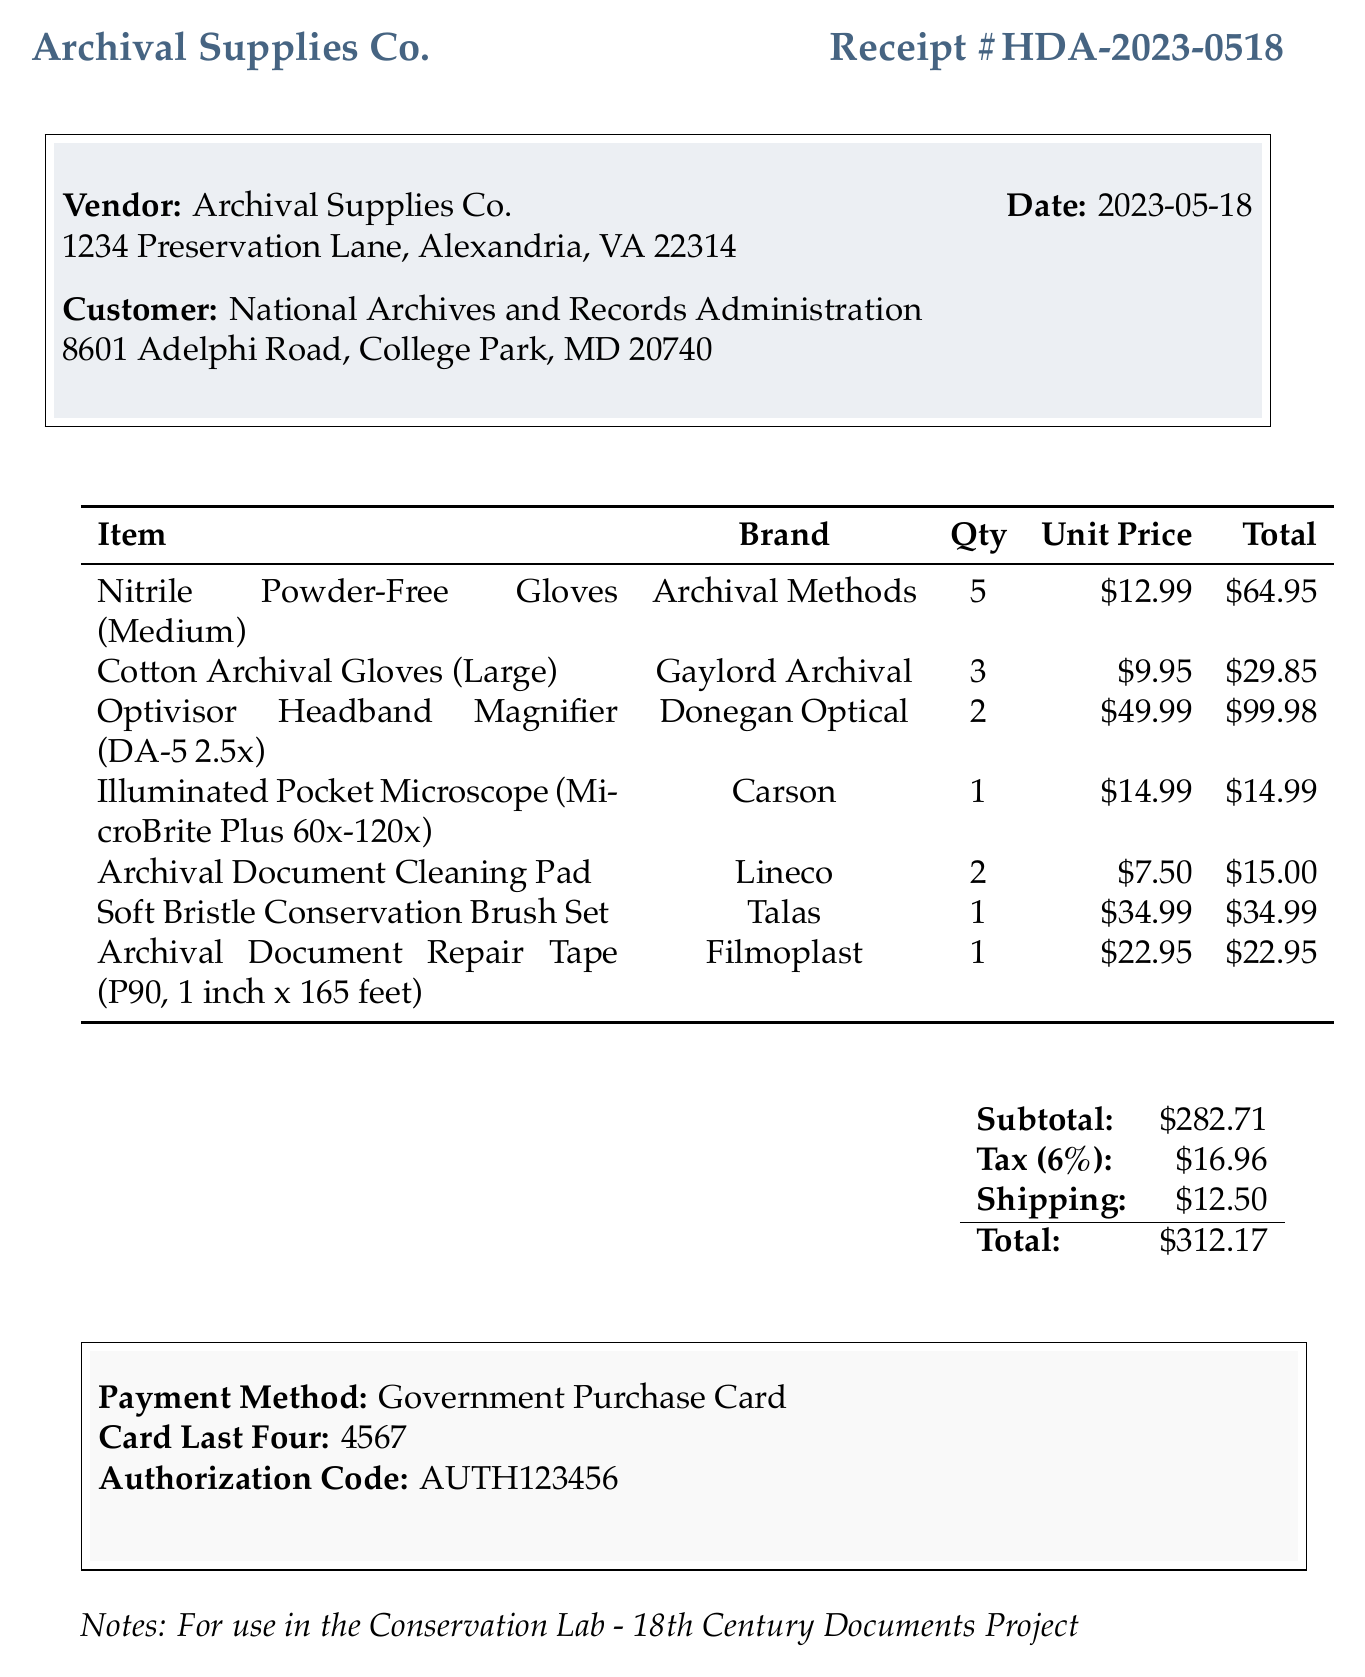what is the receipt number? The receipt number is displayed prominently at the top of the document.
Answer: HDA-2023-0518 what is the date of the purchase? The date of the purchase is listed in the header section of the document.
Answer: 2023-05-18 who is the vendor? The vendor's name is specified at the beginning of the receipt.
Answer: Archival Supplies Co how many Cotton Archival Gloves were purchased? The quantity of Cotton Archival Gloves can be found in the itemized list of purchased items.
Answer: 3 what is the total amount before tax? The subtotal before tax is indicated in the summary section of the receipt.
Answer: 282.71 what payment method was used? The payment method is detailed toward the end of the document.
Answer: Government Purchase Card what is the tax amount? The document specifies the tax amount as part of the summary calculations.
Answer: 16.96 how many items are listed in total? The total number of items can be counted from the list presented in the receipt.
Answer: 7 for which project were these supplies purchased? The purpose of the purchase is noted in the remarks section at the end of the receipt.
Answer: 18th Century Documents Project 